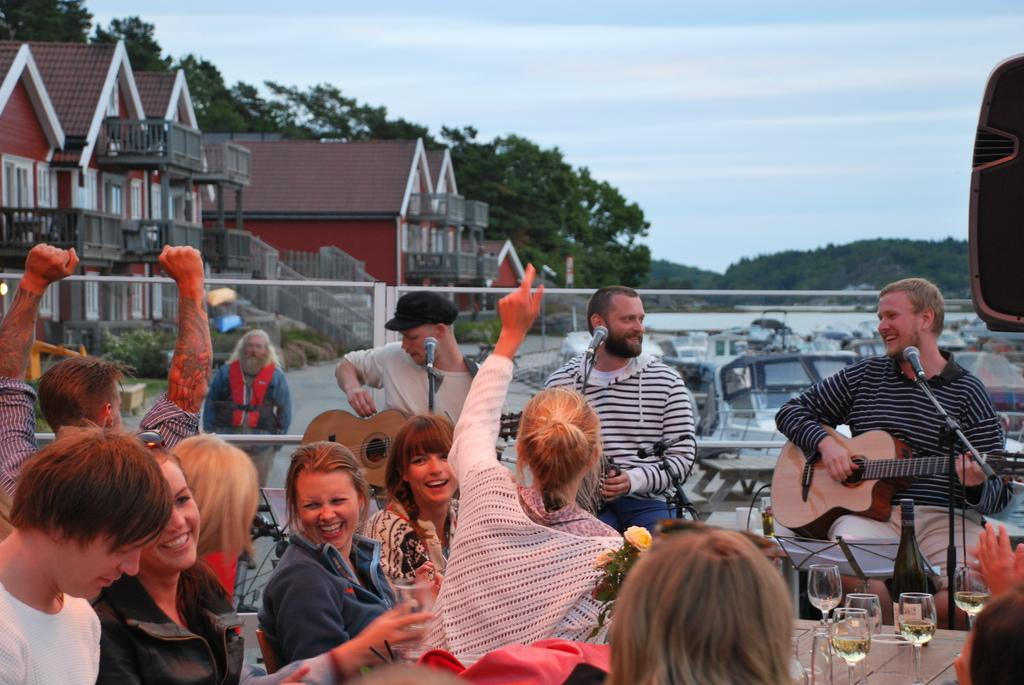How many musicians are playing music in the image? There are three people playing music in the image. Where is the music being played? The music is being played at a restaurant. What are the people in front of the musicians doing? These people are sitting at tables and enjoying the music. What type of wood can be seen in the books on the tables? There are no books or wood present in the image; it features musicians playing music at a restaurant. 